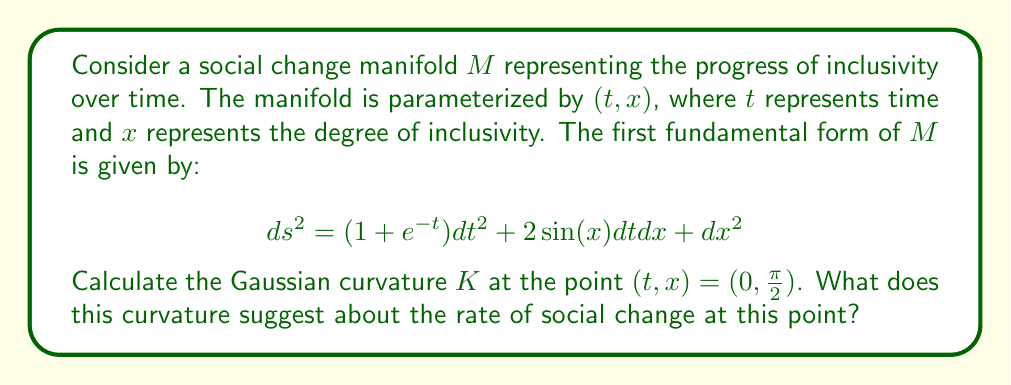Provide a solution to this math problem. To calculate the Gaussian curvature, we'll follow these steps:

1) First, we need to identify the coefficients of the first fundamental form:
   $E = 1 + e^{-t}$
   $F = \sin(x)$
   $G = 1$

2) Next, we need to calculate the second fundamental form coefficients. For this, we need to compute the partial derivatives:
   $\frac{\partial E}{\partial t} = -e^{-t}$
   $\frac{\partial E}{\partial x} = 0$
   $\frac{\partial F}{\partial t} = 0$
   $\frac{\partial F}{\partial x} = \cos(x)$
   $\frac{\partial G}{\partial t} = 0$
   $\frac{\partial G}{\partial x} = 0$

3) Now we can calculate the Christoffel symbols:
   $\Gamma_{11}^1 = \frac{E_t}{2E} = -\frac{e^{-t}}{2(1+e^{-t})}$
   $\Gamma_{12}^1 = \Gamma_{21}^1 = \frac{E_x}{2E} = 0$
   $\Gamma_{22}^1 = \frac{F_x - G_t}{E} = \frac{\cos(x)}{1+e^{-t}}$
   $\Gamma_{11}^2 = \frac{F_t - E_x}{2G} = 0$
   $\Gamma_{12}^2 = \Gamma_{21}^2 = \frac{G_x}{2G} = 0$
   $\Gamma_{22}^2 = \frac{G_x}{2G} = 0$

4) The Gaussian curvature is given by:
   $$K = -\frac{1}{E}\left(\frac{\partial \Gamma_{22}^1}{\partial t} - \frac{\partial \Gamma_{12}^2}{\partial t} + \Gamma_{22}^1\Gamma_{11}^1 + \Gamma_{12}^2\Gamma_{22}^1 - (\Gamma_{12}^1)^2 - (\Gamma_{22}^2)^2\right)$$

5) Let's calculate each term:
   $\frac{\partial \Gamma_{22}^1}{\partial t} = \frac{e^{-t}\cos(x)}{(1+e^{-t})^2}$
   $\frac{\partial \Gamma_{12}^2}{\partial t} = 0$
   $\Gamma_{22}^1\Gamma_{11}^1 = \frac{\cos(x)}{1+e^{-t}} \cdot (-\frac{e^{-t}}{2(1+e^{-t})}) = -\frac{e^{-t}\cos(x)}{2(1+e^{-t})^2}$
   $\Gamma_{12}^2\Gamma_{22}^1 = 0$
   $(\Gamma_{12}^1)^2 = 0$
   $(\Gamma_{22}^2)^2 = 0$

6) Substituting these into the formula for $K$:
   $$K = -\frac{1}{1+e^{-t}}\left(\frac{e^{-t}\cos(x)}{(1+e^{-t})^2} - \frac{e^{-t}\cos(x)}{2(1+e^{-t})^2}\right) = -\frac{e^{-t}\cos(x)}{2(1+e^{-t})^3}$$

7) At the point $(t, x) = (0, \frac{\pi}{2})$:
   $$K = -\frac{e^{0}\cos(\frac{\pi}{2})}{2(1+e^{0})^3} = 0$$

The Gaussian curvature at this point is 0, suggesting that the social change manifold is locally flat at this point. This indicates that the rate of social change is neither accelerating nor decelerating, but progressing at a steady pace.
Answer: $K = 0$ 